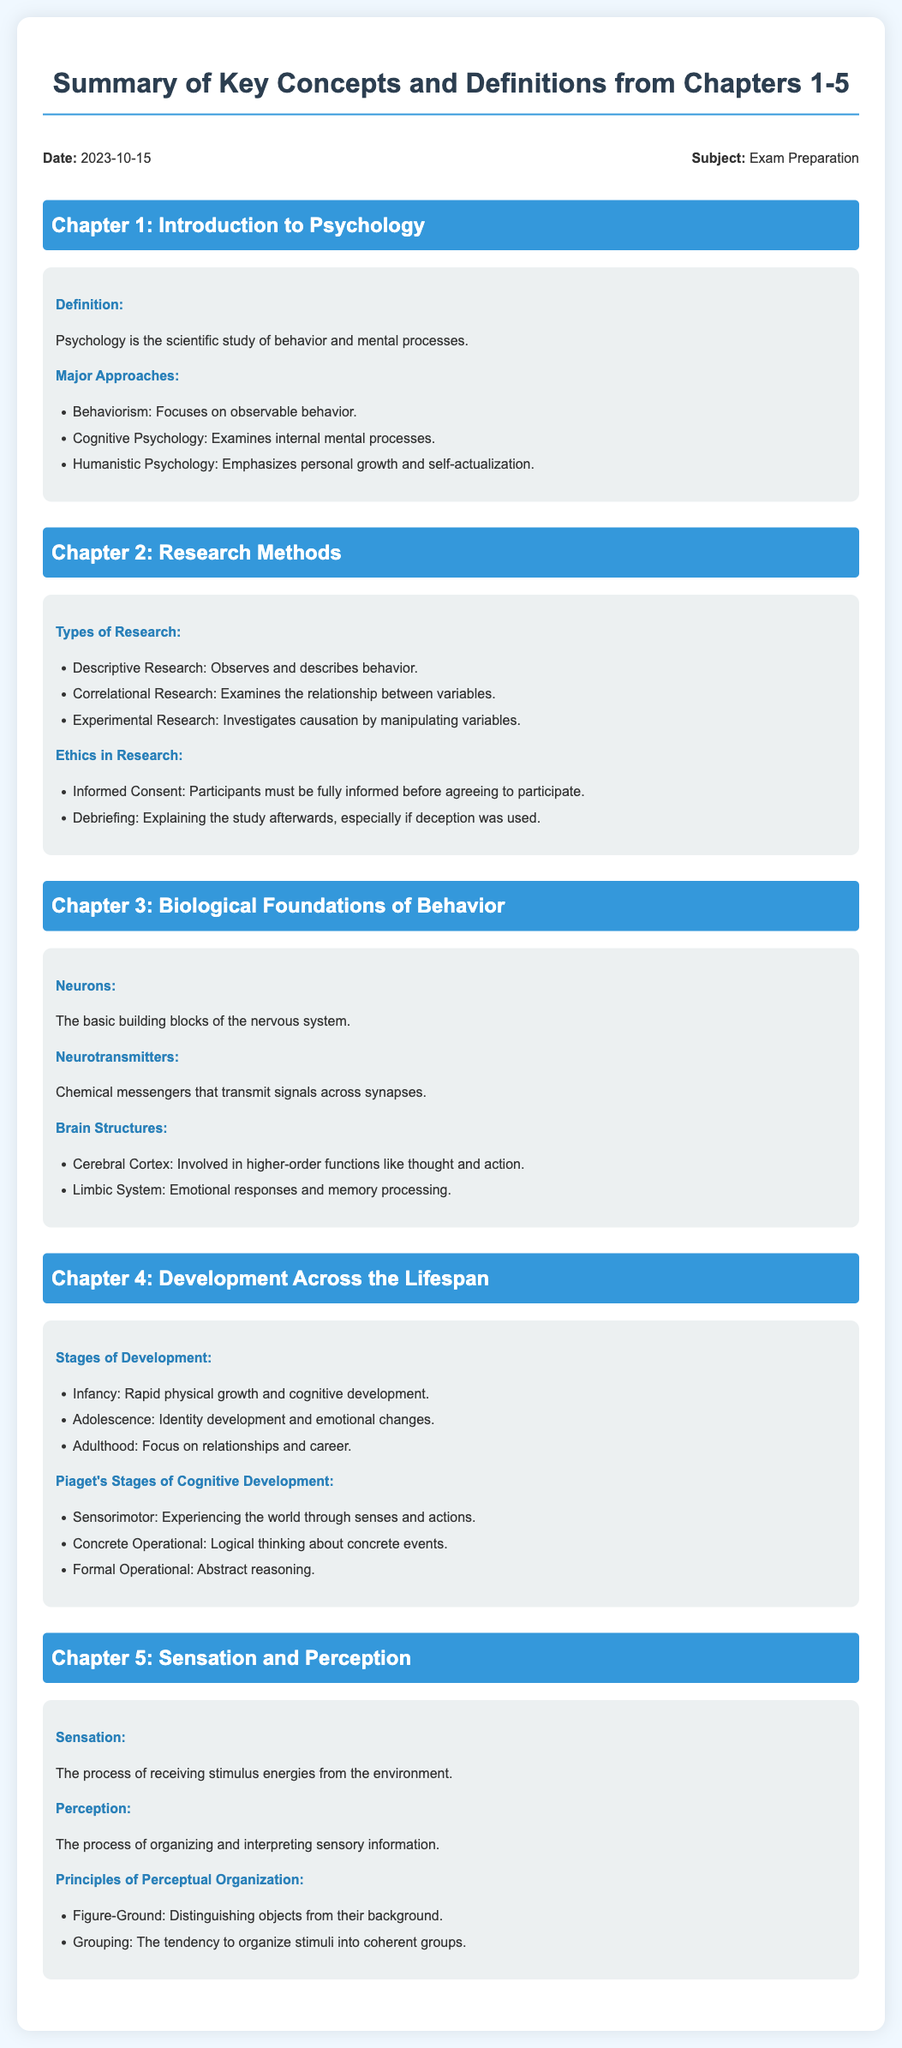What is the definition of psychology? The definition is stated clearly in Chapter 1: Psychology is the scientific study of behavior and mental processes.
Answer: Psychology is the scientific study of behavior and mental processes What are the major approaches to psychology? Chapter 1 lists three major approaches: Behaviorism, Cognitive Psychology, and Humanistic Psychology.
Answer: Behaviorism, Cognitive Psychology, Humanistic Psychology What type of research examines the relationship between variables? This information is found in Chapter 2, which describes Correlational Research as the type that examines the relationship between variables.
Answer: Correlational Research What is one ethical requirement in research? Chapter 2 highlights Informed Consent as a key ethical requirement where participants must be fully informed before agreeing to participate.
Answer: Informed Consent What are the two main types of processes discussed in Chapter 5? Chapter 5 defines Sensation and Perception as the two main processes related to sensory information.
Answer: Sensation and Perception Which brain structure is involved in higher-order functions? In Chapter 3, the Cerebral Cortex is identified as the brain structure involved in higher-order functions like thought and action.
Answer: Cerebral Cortex What is the first stage of Piaget's Stages of Cognitive Development? Chapter 4 specifies that the first stage is Sensorimotor, focusing on experiencing the world through senses and actions.
Answer: Sensorimotor Which stage of development focuses on identity development and emotional changes? Chapter 4 states that Adolescence is the stage of development that focuses on identity development and emotional changes.
Answer: Adolescence 